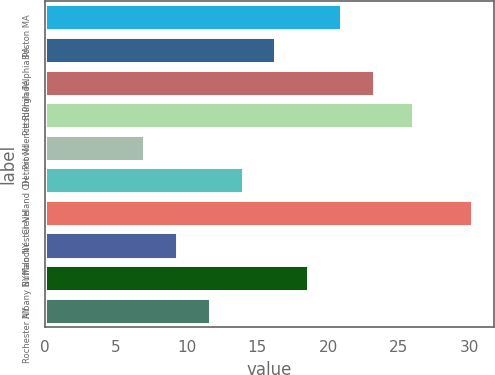Convert chart. <chart><loc_0><loc_0><loc_500><loc_500><bar_chart><fcel>Boston MA<fcel>Philadelphia PA<fcel>Pittsburgh PA<fcel>Providence RI<fcel>Detroit MI<fcel>Cleveland OH<fcel>Manchester NH<fcel>Buffalo NY<fcel>Albany NY<fcel>Rochester NY<nl><fcel>20.92<fcel>16.28<fcel>23.24<fcel>26<fcel>7<fcel>13.96<fcel>30.2<fcel>9.32<fcel>18.6<fcel>11.64<nl></chart> 